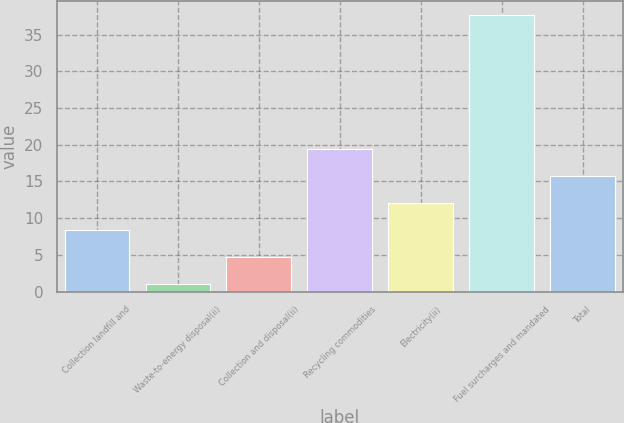Convert chart to OTSL. <chart><loc_0><loc_0><loc_500><loc_500><bar_chart><fcel>Collection landfill and<fcel>Waste-to-energy disposal(ii)<fcel>Collection and disposal(ii)<fcel>Recycling commodities<fcel>Electricity(ii)<fcel>Fuel surcharges and mandated<fcel>Total<nl><fcel>8.42<fcel>1.1<fcel>4.76<fcel>19.4<fcel>12.08<fcel>37.7<fcel>15.74<nl></chart> 